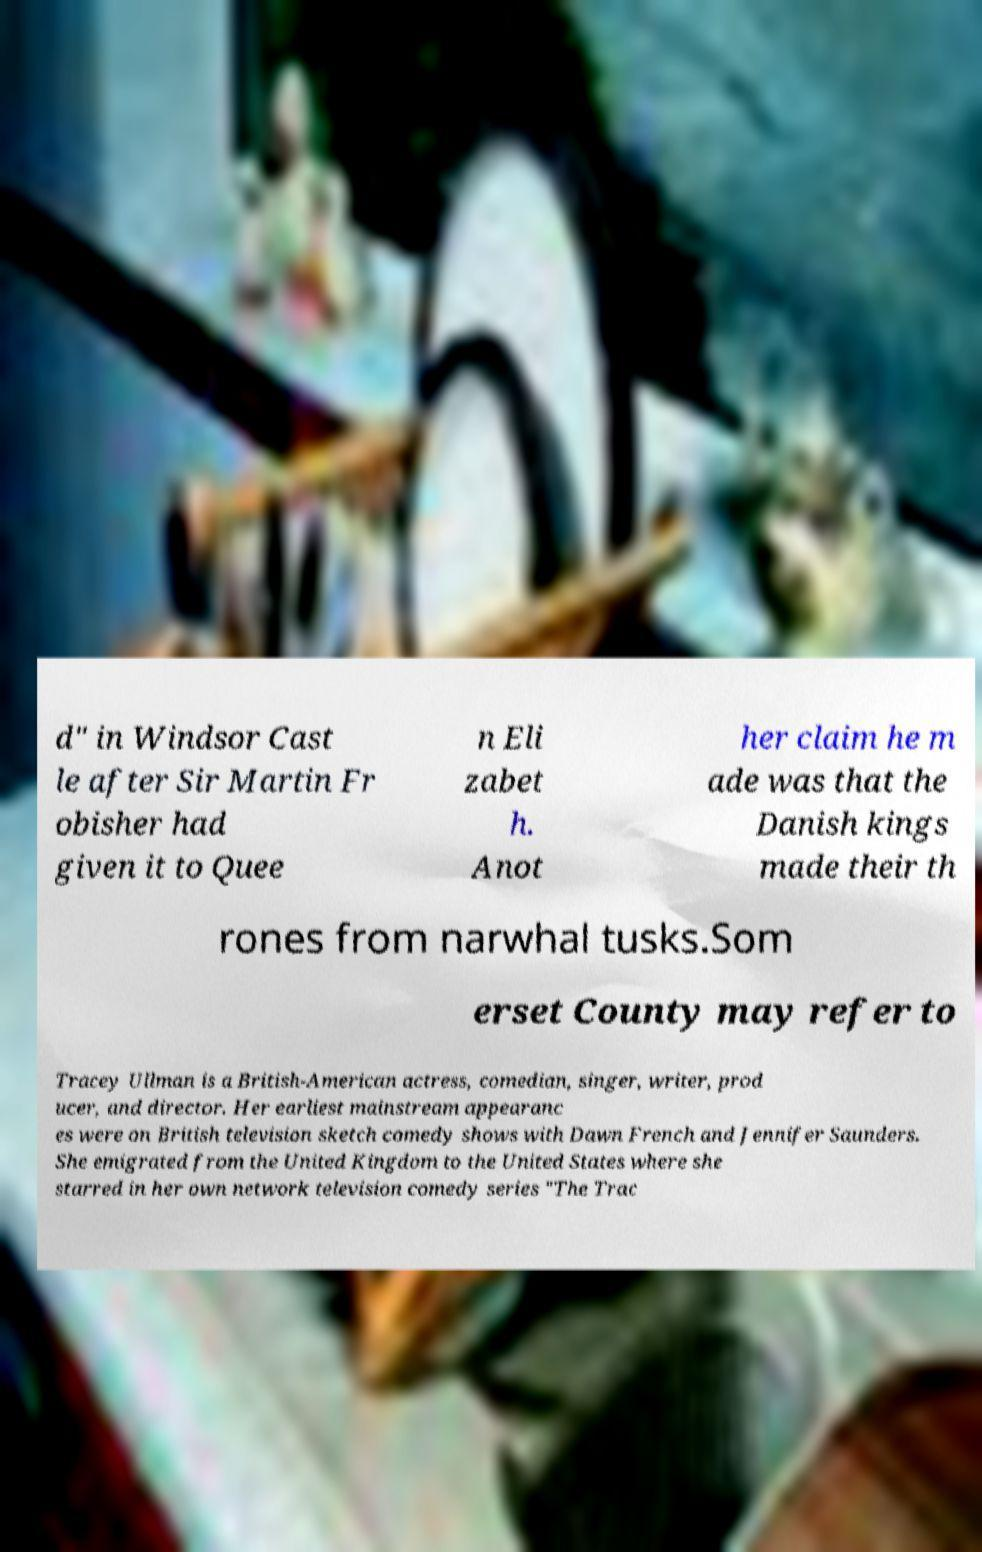What messages or text are displayed in this image? I need them in a readable, typed format. d" in Windsor Cast le after Sir Martin Fr obisher had given it to Quee n Eli zabet h. Anot her claim he m ade was that the Danish kings made their th rones from narwhal tusks.Som erset County may refer to Tracey Ullman is a British-American actress, comedian, singer, writer, prod ucer, and director. Her earliest mainstream appearanc es were on British television sketch comedy shows with Dawn French and Jennifer Saunders. She emigrated from the United Kingdom to the United States where she starred in her own network television comedy series "The Trac 